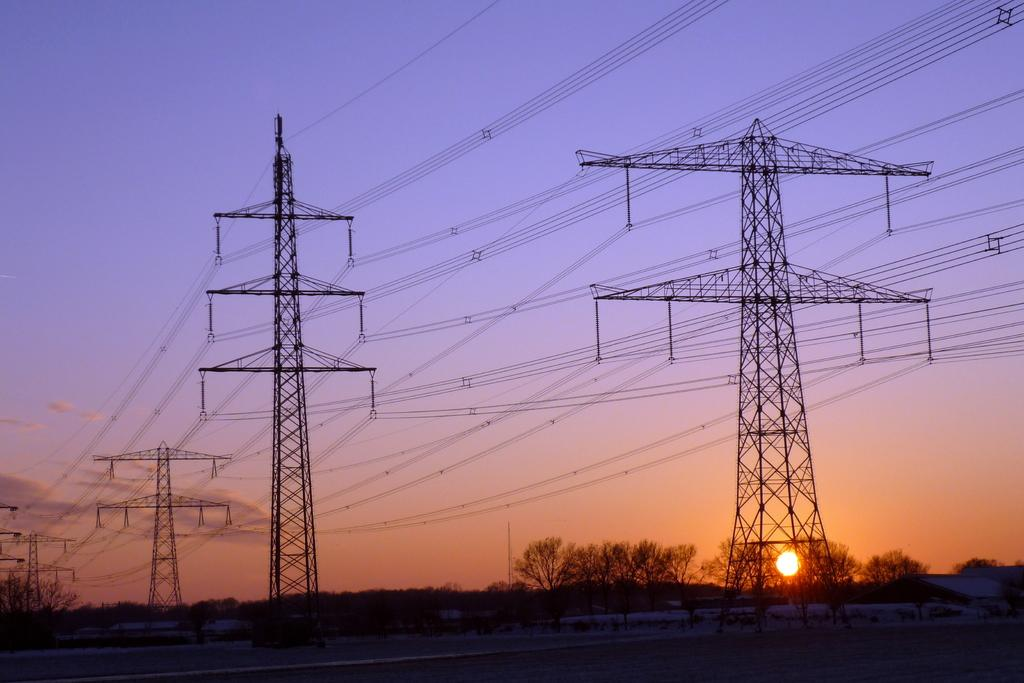What can be seen in the background of the image? There are trees and towers in the background of the image. What is on the towers? There are wires on the towers. What is the weather like in the image? The sun is visible in the image, suggesting a clear day. How many cows are grazing in the foreground of the image? There are no cows present in the image; it features trees, towers, and wires in the background. What advice does the father give in the image? There is no father or any dialogue present in the image. 